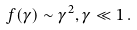<formula> <loc_0><loc_0><loc_500><loc_500>f ( \gamma ) \sim \gamma ^ { 2 } , \gamma \ll 1 \, .</formula> 